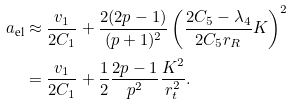Convert formula to latex. <formula><loc_0><loc_0><loc_500><loc_500>a _ { \text {el} } & \approx \frac { v _ { 1 } } { 2 C _ { 1 } } + \frac { 2 ( 2 p - 1 ) } { ( p + 1 ) ^ { 2 } } \left ( \frac { 2 C _ { 5 } - \lambda _ { 4 } } { 2 C _ { 5 } r _ { R } } K \right ) ^ { 2 } \\ & = \frac { v _ { 1 } } { 2 C _ { 1 } } + \frac { 1 } { 2 } \frac { 2 p - 1 } { p ^ { 2 } } \frac { K ^ { 2 } } { r _ { t } ^ { 2 } } .</formula> 